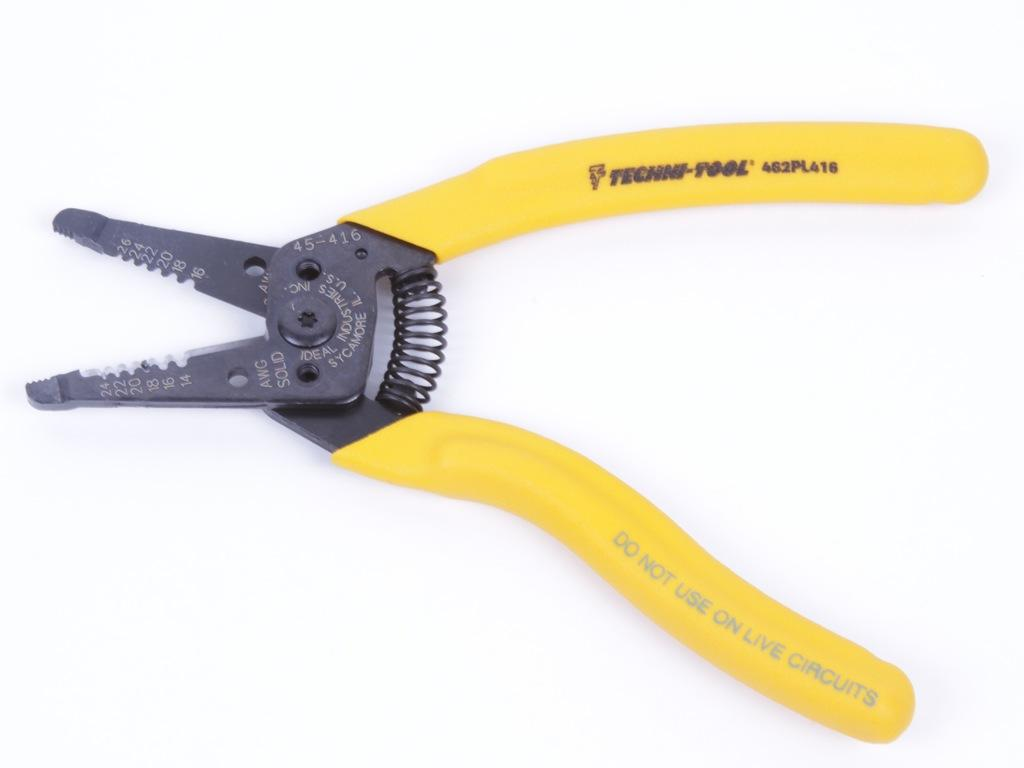<image>
Share a concise interpretation of the image provided. Techni-Tool brand pliers with a yellow handle, not to be used on live circuits. 